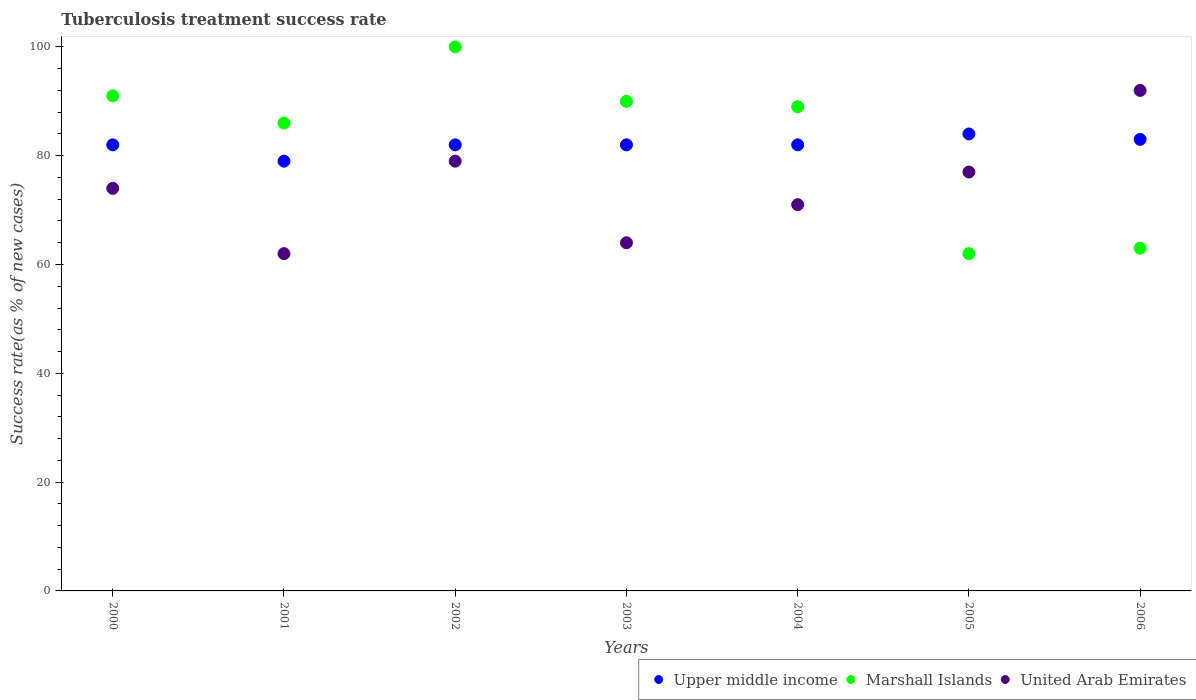What is the tuberculosis treatment success rate in Marshall Islands in 2000?
Offer a very short reply. 91. Across all years, what is the maximum tuberculosis treatment success rate in Marshall Islands?
Provide a succinct answer. 100. Across all years, what is the minimum tuberculosis treatment success rate in Upper middle income?
Give a very brief answer. 79. In which year was the tuberculosis treatment success rate in Upper middle income minimum?
Keep it short and to the point. 2001. What is the total tuberculosis treatment success rate in United Arab Emirates in the graph?
Provide a succinct answer. 519. What is the average tuberculosis treatment success rate in United Arab Emirates per year?
Keep it short and to the point. 74.14. In the year 2001, what is the difference between the tuberculosis treatment success rate in Marshall Islands and tuberculosis treatment success rate in Upper middle income?
Offer a very short reply. 7. In how many years, is the tuberculosis treatment success rate in United Arab Emirates greater than 16 %?
Your answer should be compact. 7. What is the ratio of the tuberculosis treatment success rate in Marshall Islands in 2000 to that in 2005?
Give a very brief answer. 1.47. Is the difference between the tuberculosis treatment success rate in Marshall Islands in 2001 and 2006 greater than the difference between the tuberculosis treatment success rate in Upper middle income in 2001 and 2006?
Provide a short and direct response. Yes. What is the difference between the highest and the second highest tuberculosis treatment success rate in Marshall Islands?
Offer a very short reply. 9. What is the difference between the highest and the lowest tuberculosis treatment success rate in Upper middle income?
Your response must be concise. 5. Is it the case that in every year, the sum of the tuberculosis treatment success rate in Upper middle income and tuberculosis treatment success rate in United Arab Emirates  is greater than the tuberculosis treatment success rate in Marshall Islands?
Ensure brevity in your answer.  Yes. Is the tuberculosis treatment success rate in Marshall Islands strictly greater than the tuberculosis treatment success rate in Upper middle income over the years?
Make the answer very short. No. How many years are there in the graph?
Your answer should be very brief. 7. What is the difference between two consecutive major ticks on the Y-axis?
Keep it short and to the point. 20. Are the values on the major ticks of Y-axis written in scientific E-notation?
Your answer should be very brief. No. Does the graph contain any zero values?
Your response must be concise. No. Does the graph contain grids?
Provide a short and direct response. No. How are the legend labels stacked?
Provide a succinct answer. Horizontal. What is the title of the graph?
Your answer should be very brief. Tuberculosis treatment success rate. Does "Samoa" appear as one of the legend labels in the graph?
Give a very brief answer. No. What is the label or title of the Y-axis?
Your answer should be very brief. Success rate(as % of new cases). What is the Success rate(as % of new cases) in Marshall Islands in 2000?
Your answer should be very brief. 91. What is the Success rate(as % of new cases) of Upper middle income in 2001?
Your response must be concise. 79. What is the Success rate(as % of new cases) in Marshall Islands in 2001?
Provide a succinct answer. 86. What is the Success rate(as % of new cases) in United Arab Emirates in 2001?
Provide a short and direct response. 62. What is the Success rate(as % of new cases) in Upper middle income in 2002?
Give a very brief answer. 82. What is the Success rate(as % of new cases) of Marshall Islands in 2002?
Your answer should be compact. 100. What is the Success rate(as % of new cases) of United Arab Emirates in 2002?
Offer a terse response. 79. What is the Success rate(as % of new cases) of Marshall Islands in 2003?
Offer a very short reply. 90. What is the Success rate(as % of new cases) of United Arab Emirates in 2003?
Provide a succinct answer. 64. What is the Success rate(as % of new cases) in Marshall Islands in 2004?
Make the answer very short. 89. What is the Success rate(as % of new cases) in United Arab Emirates in 2004?
Provide a succinct answer. 71. What is the Success rate(as % of new cases) in Upper middle income in 2005?
Make the answer very short. 84. What is the Success rate(as % of new cases) in United Arab Emirates in 2005?
Your answer should be compact. 77. What is the Success rate(as % of new cases) of United Arab Emirates in 2006?
Make the answer very short. 92. Across all years, what is the maximum Success rate(as % of new cases) in Marshall Islands?
Provide a succinct answer. 100. Across all years, what is the maximum Success rate(as % of new cases) in United Arab Emirates?
Provide a succinct answer. 92. Across all years, what is the minimum Success rate(as % of new cases) of Upper middle income?
Your answer should be very brief. 79. Across all years, what is the minimum Success rate(as % of new cases) of Marshall Islands?
Make the answer very short. 62. Across all years, what is the minimum Success rate(as % of new cases) in United Arab Emirates?
Your answer should be compact. 62. What is the total Success rate(as % of new cases) of Upper middle income in the graph?
Ensure brevity in your answer.  574. What is the total Success rate(as % of new cases) in Marshall Islands in the graph?
Offer a very short reply. 581. What is the total Success rate(as % of new cases) of United Arab Emirates in the graph?
Your answer should be compact. 519. What is the difference between the Success rate(as % of new cases) of Marshall Islands in 2000 and that in 2001?
Your answer should be compact. 5. What is the difference between the Success rate(as % of new cases) in Marshall Islands in 2000 and that in 2003?
Offer a terse response. 1. What is the difference between the Success rate(as % of new cases) of United Arab Emirates in 2000 and that in 2004?
Your answer should be very brief. 3. What is the difference between the Success rate(as % of new cases) in Marshall Islands in 2000 and that in 2005?
Make the answer very short. 29. What is the difference between the Success rate(as % of new cases) of United Arab Emirates in 2000 and that in 2005?
Provide a short and direct response. -3. What is the difference between the Success rate(as % of new cases) in Upper middle income in 2000 and that in 2006?
Your answer should be very brief. -1. What is the difference between the Success rate(as % of new cases) in Upper middle income in 2001 and that in 2002?
Make the answer very short. -3. What is the difference between the Success rate(as % of new cases) of Marshall Islands in 2001 and that in 2002?
Provide a succinct answer. -14. What is the difference between the Success rate(as % of new cases) of United Arab Emirates in 2001 and that in 2002?
Offer a terse response. -17. What is the difference between the Success rate(as % of new cases) in Upper middle income in 2001 and that in 2003?
Your answer should be very brief. -3. What is the difference between the Success rate(as % of new cases) in Marshall Islands in 2001 and that in 2003?
Make the answer very short. -4. What is the difference between the Success rate(as % of new cases) in United Arab Emirates in 2001 and that in 2003?
Make the answer very short. -2. What is the difference between the Success rate(as % of new cases) in Upper middle income in 2001 and that in 2004?
Offer a very short reply. -3. What is the difference between the Success rate(as % of new cases) of Marshall Islands in 2001 and that in 2004?
Provide a succinct answer. -3. What is the difference between the Success rate(as % of new cases) in Upper middle income in 2001 and that in 2005?
Ensure brevity in your answer.  -5. What is the difference between the Success rate(as % of new cases) in Marshall Islands in 2001 and that in 2005?
Give a very brief answer. 24. What is the difference between the Success rate(as % of new cases) of Marshall Islands in 2001 and that in 2006?
Provide a short and direct response. 23. What is the difference between the Success rate(as % of new cases) of Upper middle income in 2002 and that in 2003?
Your response must be concise. 0. What is the difference between the Success rate(as % of new cases) of United Arab Emirates in 2002 and that in 2003?
Ensure brevity in your answer.  15. What is the difference between the Success rate(as % of new cases) of Upper middle income in 2002 and that in 2004?
Your response must be concise. 0. What is the difference between the Success rate(as % of new cases) in Marshall Islands in 2002 and that in 2004?
Provide a succinct answer. 11. What is the difference between the Success rate(as % of new cases) in Upper middle income in 2002 and that in 2006?
Your answer should be compact. -1. What is the difference between the Success rate(as % of new cases) of United Arab Emirates in 2002 and that in 2006?
Provide a succinct answer. -13. What is the difference between the Success rate(as % of new cases) in Upper middle income in 2003 and that in 2004?
Offer a terse response. 0. What is the difference between the Success rate(as % of new cases) of United Arab Emirates in 2003 and that in 2004?
Offer a terse response. -7. What is the difference between the Success rate(as % of new cases) of Upper middle income in 2003 and that in 2005?
Offer a terse response. -2. What is the difference between the Success rate(as % of new cases) in Marshall Islands in 2003 and that in 2006?
Offer a terse response. 27. What is the difference between the Success rate(as % of new cases) of United Arab Emirates in 2003 and that in 2006?
Make the answer very short. -28. What is the difference between the Success rate(as % of new cases) of United Arab Emirates in 2004 and that in 2006?
Provide a succinct answer. -21. What is the difference between the Success rate(as % of new cases) in Marshall Islands in 2005 and that in 2006?
Your answer should be compact. -1. What is the difference between the Success rate(as % of new cases) of Upper middle income in 2000 and the Success rate(as % of new cases) of Marshall Islands in 2001?
Provide a succinct answer. -4. What is the difference between the Success rate(as % of new cases) in Upper middle income in 2000 and the Success rate(as % of new cases) in United Arab Emirates in 2001?
Your response must be concise. 20. What is the difference between the Success rate(as % of new cases) in Upper middle income in 2000 and the Success rate(as % of new cases) in United Arab Emirates in 2003?
Your response must be concise. 18. What is the difference between the Success rate(as % of new cases) of Upper middle income in 2000 and the Success rate(as % of new cases) of Marshall Islands in 2004?
Provide a succinct answer. -7. What is the difference between the Success rate(as % of new cases) of Upper middle income in 2000 and the Success rate(as % of new cases) of United Arab Emirates in 2004?
Ensure brevity in your answer.  11. What is the difference between the Success rate(as % of new cases) in Marshall Islands in 2000 and the Success rate(as % of new cases) in United Arab Emirates in 2004?
Your response must be concise. 20. What is the difference between the Success rate(as % of new cases) in Upper middle income in 2000 and the Success rate(as % of new cases) in Marshall Islands in 2005?
Offer a very short reply. 20. What is the difference between the Success rate(as % of new cases) of Upper middle income in 2000 and the Success rate(as % of new cases) of United Arab Emirates in 2005?
Provide a succinct answer. 5. What is the difference between the Success rate(as % of new cases) in Marshall Islands in 2000 and the Success rate(as % of new cases) in United Arab Emirates in 2006?
Offer a terse response. -1. What is the difference between the Success rate(as % of new cases) in Upper middle income in 2001 and the Success rate(as % of new cases) in United Arab Emirates in 2002?
Provide a succinct answer. 0. What is the difference between the Success rate(as % of new cases) in Upper middle income in 2001 and the Success rate(as % of new cases) in Marshall Islands in 2003?
Your answer should be very brief. -11. What is the difference between the Success rate(as % of new cases) of Upper middle income in 2001 and the Success rate(as % of new cases) of United Arab Emirates in 2004?
Give a very brief answer. 8. What is the difference between the Success rate(as % of new cases) of Marshall Islands in 2001 and the Success rate(as % of new cases) of United Arab Emirates in 2004?
Offer a very short reply. 15. What is the difference between the Success rate(as % of new cases) in Upper middle income in 2001 and the Success rate(as % of new cases) in Marshall Islands in 2006?
Your answer should be very brief. 16. What is the difference between the Success rate(as % of new cases) in Upper middle income in 2001 and the Success rate(as % of new cases) in United Arab Emirates in 2006?
Keep it short and to the point. -13. What is the difference between the Success rate(as % of new cases) in Marshall Islands in 2001 and the Success rate(as % of new cases) in United Arab Emirates in 2006?
Your response must be concise. -6. What is the difference between the Success rate(as % of new cases) of Upper middle income in 2002 and the Success rate(as % of new cases) of United Arab Emirates in 2003?
Make the answer very short. 18. What is the difference between the Success rate(as % of new cases) in Upper middle income in 2002 and the Success rate(as % of new cases) in United Arab Emirates in 2004?
Keep it short and to the point. 11. What is the difference between the Success rate(as % of new cases) of Upper middle income in 2002 and the Success rate(as % of new cases) of Marshall Islands in 2005?
Your answer should be compact. 20. What is the difference between the Success rate(as % of new cases) in Upper middle income in 2002 and the Success rate(as % of new cases) in United Arab Emirates in 2005?
Make the answer very short. 5. What is the difference between the Success rate(as % of new cases) in Marshall Islands in 2002 and the Success rate(as % of new cases) in United Arab Emirates in 2005?
Your answer should be very brief. 23. What is the difference between the Success rate(as % of new cases) in Upper middle income in 2002 and the Success rate(as % of new cases) in Marshall Islands in 2006?
Offer a terse response. 19. What is the difference between the Success rate(as % of new cases) of Upper middle income in 2002 and the Success rate(as % of new cases) of United Arab Emirates in 2006?
Your answer should be very brief. -10. What is the difference between the Success rate(as % of new cases) of Marshall Islands in 2002 and the Success rate(as % of new cases) of United Arab Emirates in 2006?
Your answer should be compact. 8. What is the difference between the Success rate(as % of new cases) in Upper middle income in 2003 and the Success rate(as % of new cases) in Marshall Islands in 2004?
Offer a terse response. -7. What is the difference between the Success rate(as % of new cases) in Upper middle income in 2003 and the Success rate(as % of new cases) in United Arab Emirates in 2004?
Give a very brief answer. 11. What is the difference between the Success rate(as % of new cases) of Marshall Islands in 2003 and the Success rate(as % of new cases) of United Arab Emirates in 2004?
Provide a short and direct response. 19. What is the difference between the Success rate(as % of new cases) of Upper middle income in 2003 and the Success rate(as % of new cases) of United Arab Emirates in 2005?
Your response must be concise. 5. What is the difference between the Success rate(as % of new cases) of Marshall Islands in 2003 and the Success rate(as % of new cases) of United Arab Emirates in 2005?
Your response must be concise. 13. What is the difference between the Success rate(as % of new cases) of Upper middle income in 2004 and the Success rate(as % of new cases) of United Arab Emirates in 2005?
Your response must be concise. 5. What is the difference between the Success rate(as % of new cases) in Marshall Islands in 2004 and the Success rate(as % of new cases) in United Arab Emirates in 2005?
Ensure brevity in your answer.  12. What is the difference between the Success rate(as % of new cases) of Marshall Islands in 2004 and the Success rate(as % of new cases) of United Arab Emirates in 2006?
Offer a very short reply. -3. What is the difference between the Success rate(as % of new cases) in Upper middle income in 2005 and the Success rate(as % of new cases) in Marshall Islands in 2006?
Provide a succinct answer. 21. What is the difference between the Success rate(as % of new cases) in Marshall Islands in 2005 and the Success rate(as % of new cases) in United Arab Emirates in 2006?
Keep it short and to the point. -30. What is the average Success rate(as % of new cases) of Marshall Islands per year?
Make the answer very short. 83. What is the average Success rate(as % of new cases) of United Arab Emirates per year?
Offer a terse response. 74.14. In the year 2000, what is the difference between the Success rate(as % of new cases) of Upper middle income and Success rate(as % of new cases) of Marshall Islands?
Make the answer very short. -9. In the year 2000, what is the difference between the Success rate(as % of new cases) in Marshall Islands and Success rate(as % of new cases) in United Arab Emirates?
Give a very brief answer. 17. In the year 2001, what is the difference between the Success rate(as % of new cases) of Marshall Islands and Success rate(as % of new cases) of United Arab Emirates?
Your answer should be compact. 24. In the year 2002, what is the difference between the Success rate(as % of new cases) in Marshall Islands and Success rate(as % of new cases) in United Arab Emirates?
Your response must be concise. 21. In the year 2004, what is the difference between the Success rate(as % of new cases) in Upper middle income and Success rate(as % of new cases) in United Arab Emirates?
Your answer should be very brief. 11. In the year 2005, what is the difference between the Success rate(as % of new cases) of Upper middle income and Success rate(as % of new cases) of Marshall Islands?
Your response must be concise. 22. In the year 2005, what is the difference between the Success rate(as % of new cases) in Marshall Islands and Success rate(as % of new cases) in United Arab Emirates?
Your response must be concise. -15. In the year 2006, what is the difference between the Success rate(as % of new cases) in Upper middle income and Success rate(as % of new cases) in Marshall Islands?
Your answer should be very brief. 20. What is the ratio of the Success rate(as % of new cases) of Upper middle income in 2000 to that in 2001?
Your answer should be very brief. 1.04. What is the ratio of the Success rate(as % of new cases) in Marshall Islands in 2000 to that in 2001?
Keep it short and to the point. 1.06. What is the ratio of the Success rate(as % of new cases) of United Arab Emirates in 2000 to that in 2001?
Provide a short and direct response. 1.19. What is the ratio of the Success rate(as % of new cases) in Marshall Islands in 2000 to that in 2002?
Provide a succinct answer. 0.91. What is the ratio of the Success rate(as % of new cases) of United Arab Emirates in 2000 to that in 2002?
Offer a terse response. 0.94. What is the ratio of the Success rate(as % of new cases) in Marshall Islands in 2000 to that in 2003?
Keep it short and to the point. 1.01. What is the ratio of the Success rate(as % of new cases) in United Arab Emirates in 2000 to that in 2003?
Your answer should be very brief. 1.16. What is the ratio of the Success rate(as % of new cases) of Marshall Islands in 2000 to that in 2004?
Your answer should be compact. 1.02. What is the ratio of the Success rate(as % of new cases) of United Arab Emirates in 2000 to that in 2004?
Your answer should be compact. 1.04. What is the ratio of the Success rate(as % of new cases) of Upper middle income in 2000 to that in 2005?
Offer a very short reply. 0.98. What is the ratio of the Success rate(as % of new cases) in Marshall Islands in 2000 to that in 2005?
Keep it short and to the point. 1.47. What is the ratio of the Success rate(as % of new cases) of United Arab Emirates in 2000 to that in 2005?
Ensure brevity in your answer.  0.96. What is the ratio of the Success rate(as % of new cases) of Marshall Islands in 2000 to that in 2006?
Your response must be concise. 1.44. What is the ratio of the Success rate(as % of new cases) in United Arab Emirates in 2000 to that in 2006?
Ensure brevity in your answer.  0.8. What is the ratio of the Success rate(as % of new cases) in Upper middle income in 2001 to that in 2002?
Offer a very short reply. 0.96. What is the ratio of the Success rate(as % of new cases) of Marshall Islands in 2001 to that in 2002?
Your answer should be very brief. 0.86. What is the ratio of the Success rate(as % of new cases) in United Arab Emirates in 2001 to that in 2002?
Offer a terse response. 0.78. What is the ratio of the Success rate(as % of new cases) in Upper middle income in 2001 to that in 2003?
Make the answer very short. 0.96. What is the ratio of the Success rate(as % of new cases) in Marshall Islands in 2001 to that in 2003?
Keep it short and to the point. 0.96. What is the ratio of the Success rate(as % of new cases) in United Arab Emirates in 2001 to that in 2003?
Give a very brief answer. 0.97. What is the ratio of the Success rate(as % of new cases) in Upper middle income in 2001 to that in 2004?
Offer a very short reply. 0.96. What is the ratio of the Success rate(as % of new cases) of Marshall Islands in 2001 to that in 2004?
Keep it short and to the point. 0.97. What is the ratio of the Success rate(as % of new cases) of United Arab Emirates in 2001 to that in 2004?
Give a very brief answer. 0.87. What is the ratio of the Success rate(as % of new cases) of Upper middle income in 2001 to that in 2005?
Keep it short and to the point. 0.94. What is the ratio of the Success rate(as % of new cases) in Marshall Islands in 2001 to that in 2005?
Your answer should be very brief. 1.39. What is the ratio of the Success rate(as % of new cases) of United Arab Emirates in 2001 to that in 2005?
Provide a succinct answer. 0.81. What is the ratio of the Success rate(as % of new cases) in Upper middle income in 2001 to that in 2006?
Offer a very short reply. 0.95. What is the ratio of the Success rate(as % of new cases) in Marshall Islands in 2001 to that in 2006?
Keep it short and to the point. 1.37. What is the ratio of the Success rate(as % of new cases) of United Arab Emirates in 2001 to that in 2006?
Provide a succinct answer. 0.67. What is the ratio of the Success rate(as % of new cases) of Marshall Islands in 2002 to that in 2003?
Offer a very short reply. 1.11. What is the ratio of the Success rate(as % of new cases) of United Arab Emirates in 2002 to that in 2003?
Your answer should be very brief. 1.23. What is the ratio of the Success rate(as % of new cases) in Upper middle income in 2002 to that in 2004?
Provide a short and direct response. 1. What is the ratio of the Success rate(as % of new cases) of Marshall Islands in 2002 to that in 2004?
Give a very brief answer. 1.12. What is the ratio of the Success rate(as % of new cases) of United Arab Emirates in 2002 to that in 2004?
Your answer should be very brief. 1.11. What is the ratio of the Success rate(as % of new cases) in Upper middle income in 2002 to that in 2005?
Keep it short and to the point. 0.98. What is the ratio of the Success rate(as % of new cases) in Marshall Islands in 2002 to that in 2005?
Offer a very short reply. 1.61. What is the ratio of the Success rate(as % of new cases) of Upper middle income in 2002 to that in 2006?
Provide a succinct answer. 0.99. What is the ratio of the Success rate(as % of new cases) in Marshall Islands in 2002 to that in 2006?
Your response must be concise. 1.59. What is the ratio of the Success rate(as % of new cases) of United Arab Emirates in 2002 to that in 2006?
Ensure brevity in your answer.  0.86. What is the ratio of the Success rate(as % of new cases) in Upper middle income in 2003 to that in 2004?
Keep it short and to the point. 1. What is the ratio of the Success rate(as % of new cases) of Marshall Islands in 2003 to that in 2004?
Give a very brief answer. 1.01. What is the ratio of the Success rate(as % of new cases) of United Arab Emirates in 2003 to that in 2004?
Keep it short and to the point. 0.9. What is the ratio of the Success rate(as % of new cases) in Upper middle income in 2003 to that in 2005?
Offer a very short reply. 0.98. What is the ratio of the Success rate(as % of new cases) of Marshall Islands in 2003 to that in 2005?
Offer a very short reply. 1.45. What is the ratio of the Success rate(as % of new cases) of United Arab Emirates in 2003 to that in 2005?
Provide a succinct answer. 0.83. What is the ratio of the Success rate(as % of new cases) of Upper middle income in 2003 to that in 2006?
Your answer should be compact. 0.99. What is the ratio of the Success rate(as % of new cases) in Marshall Islands in 2003 to that in 2006?
Your answer should be very brief. 1.43. What is the ratio of the Success rate(as % of new cases) of United Arab Emirates in 2003 to that in 2006?
Keep it short and to the point. 0.7. What is the ratio of the Success rate(as % of new cases) in Upper middle income in 2004 to that in 2005?
Ensure brevity in your answer.  0.98. What is the ratio of the Success rate(as % of new cases) in Marshall Islands in 2004 to that in 2005?
Offer a very short reply. 1.44. What is the ratio of the Success rate(as % of new cases) of United Arab Emirates in 2004 to that in 2005?
Your response must be concise. 0.92. What is the ratio of the Success rate(as % of new cases) in Marshall Islands in 2004 to that in 2006?
Keep it short and to the point. 1.41. What is the ratio of the Success rate(as % of new cases) of United Arab Emirates in 2004 to that in 2006?
Your answer should be compact. 0.77. What is the ratio of the Success rate(as % of new cases) in Marshall Islands in 2005 to that in 2006?
Your answer should be compact. 0.98. What is the ratio of the Success rate(as % of new cases) in United Arab Emirates in 2005 to that in 2006?
Offer a very short reply. 0.84. What is the difference between the highest and the second highest Success rate(as % of new cases) of Marshall Islands?
Your answer should be very brief. 9. What is the difference between the highest and the second highest Success rate(as % of new cases) in United Arab Emirates?
Provide a short and direct response. 13. 